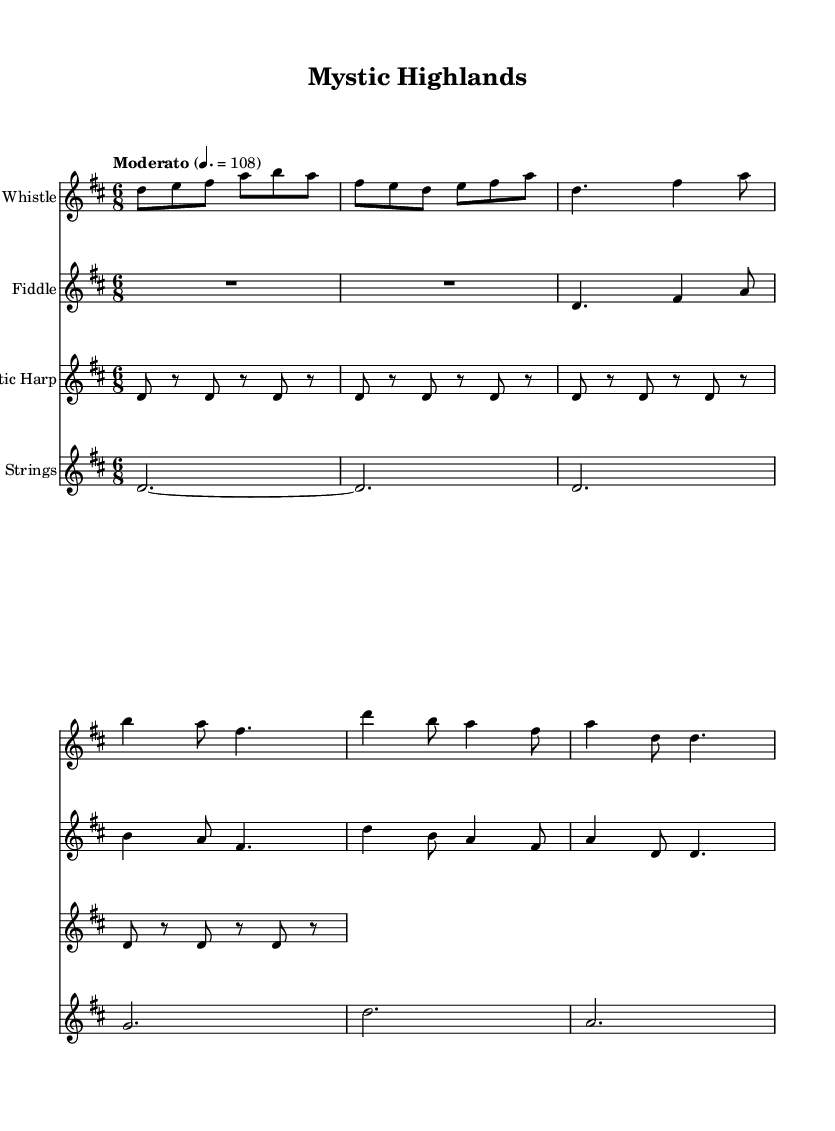What is the key signature of this music? The key signature is D major, which has two sharps (F# and C#). This can be determined by looking at the key signature indicated at the beginning of the sheet music.
Answer: D major What is the time signature of this music? The time signature is 6/8, as indicated at the beginning of the score. This means there are 6 eighth notes per measure, which creates a compound meter often associated with a lilting feel common in Celtic music.
Answer: 6/8 What is the tempo marking for this piece? The tempo marking is "Moderato" with a specific metronome marking of 108 beats per minute. This can be found written above the staff, indicating the speed of the piece.
Answer: Moderato 108 How many measures are in the verse section? The verse section consists of 4 measures, as determined by counting the number of distinct measure lines in that section of the music.
Answer: 4 What instrument plays the arpeggio pattern? The harp is indicated to play the arpeggio pattern throughout the piece. This information is found in the instrument name above the staff that contains the harp part.
Answer: Harp How many instruments are included in this score? There are four instruments included in this score, as indicated by the four separate staffs for the Irish Whistle, Fiddle, Harp, and Strings.
Answer: 4 Which part plays a longer note in the introduction section? The introduction section is played by the Irish Whistle and the Fiddle, but only the Fiddle has a rest before playing again, making its first note longer in duration compared to the Irish Whistle. The longer notes can be seen in the note lengths of each part.
Answer: Fiddle 